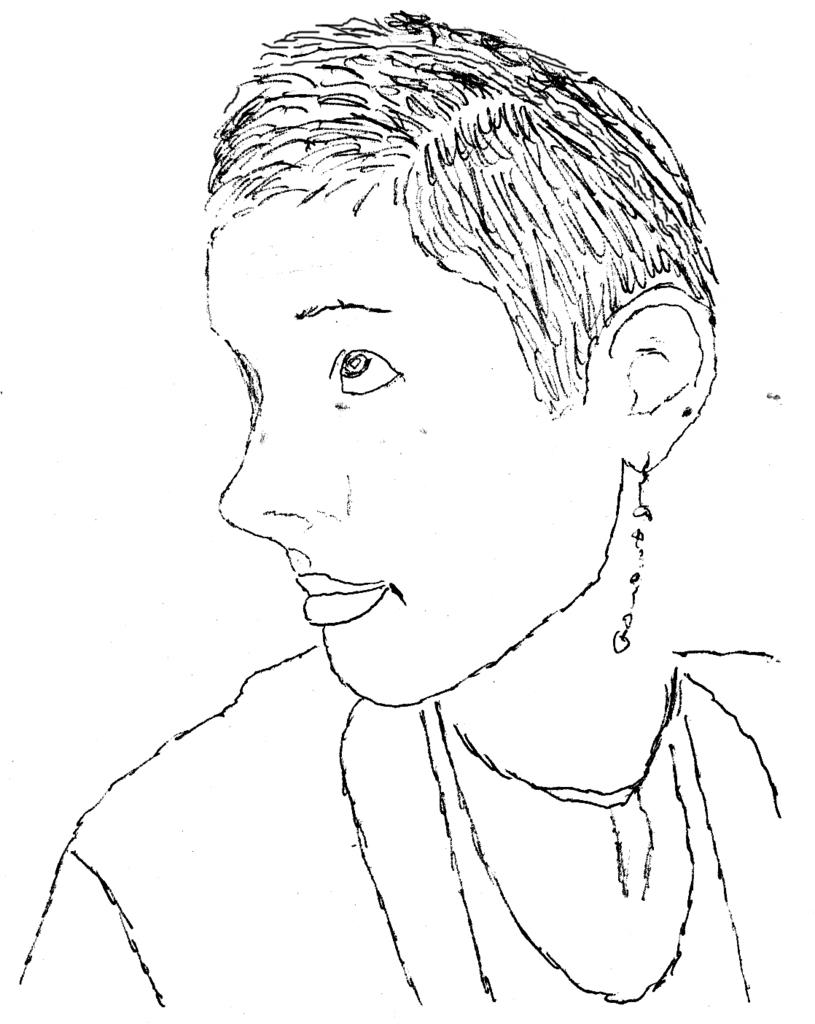What type of art is depicted in the image? The image contains a pencil drawing. What type of pot is being used by the goose in the image? There is no goose or pot present in the image; it contains a pencil drawing. What type of drink is being held by the person in the image? There is no person or drink present in the image; it contains a pencil drawing. 